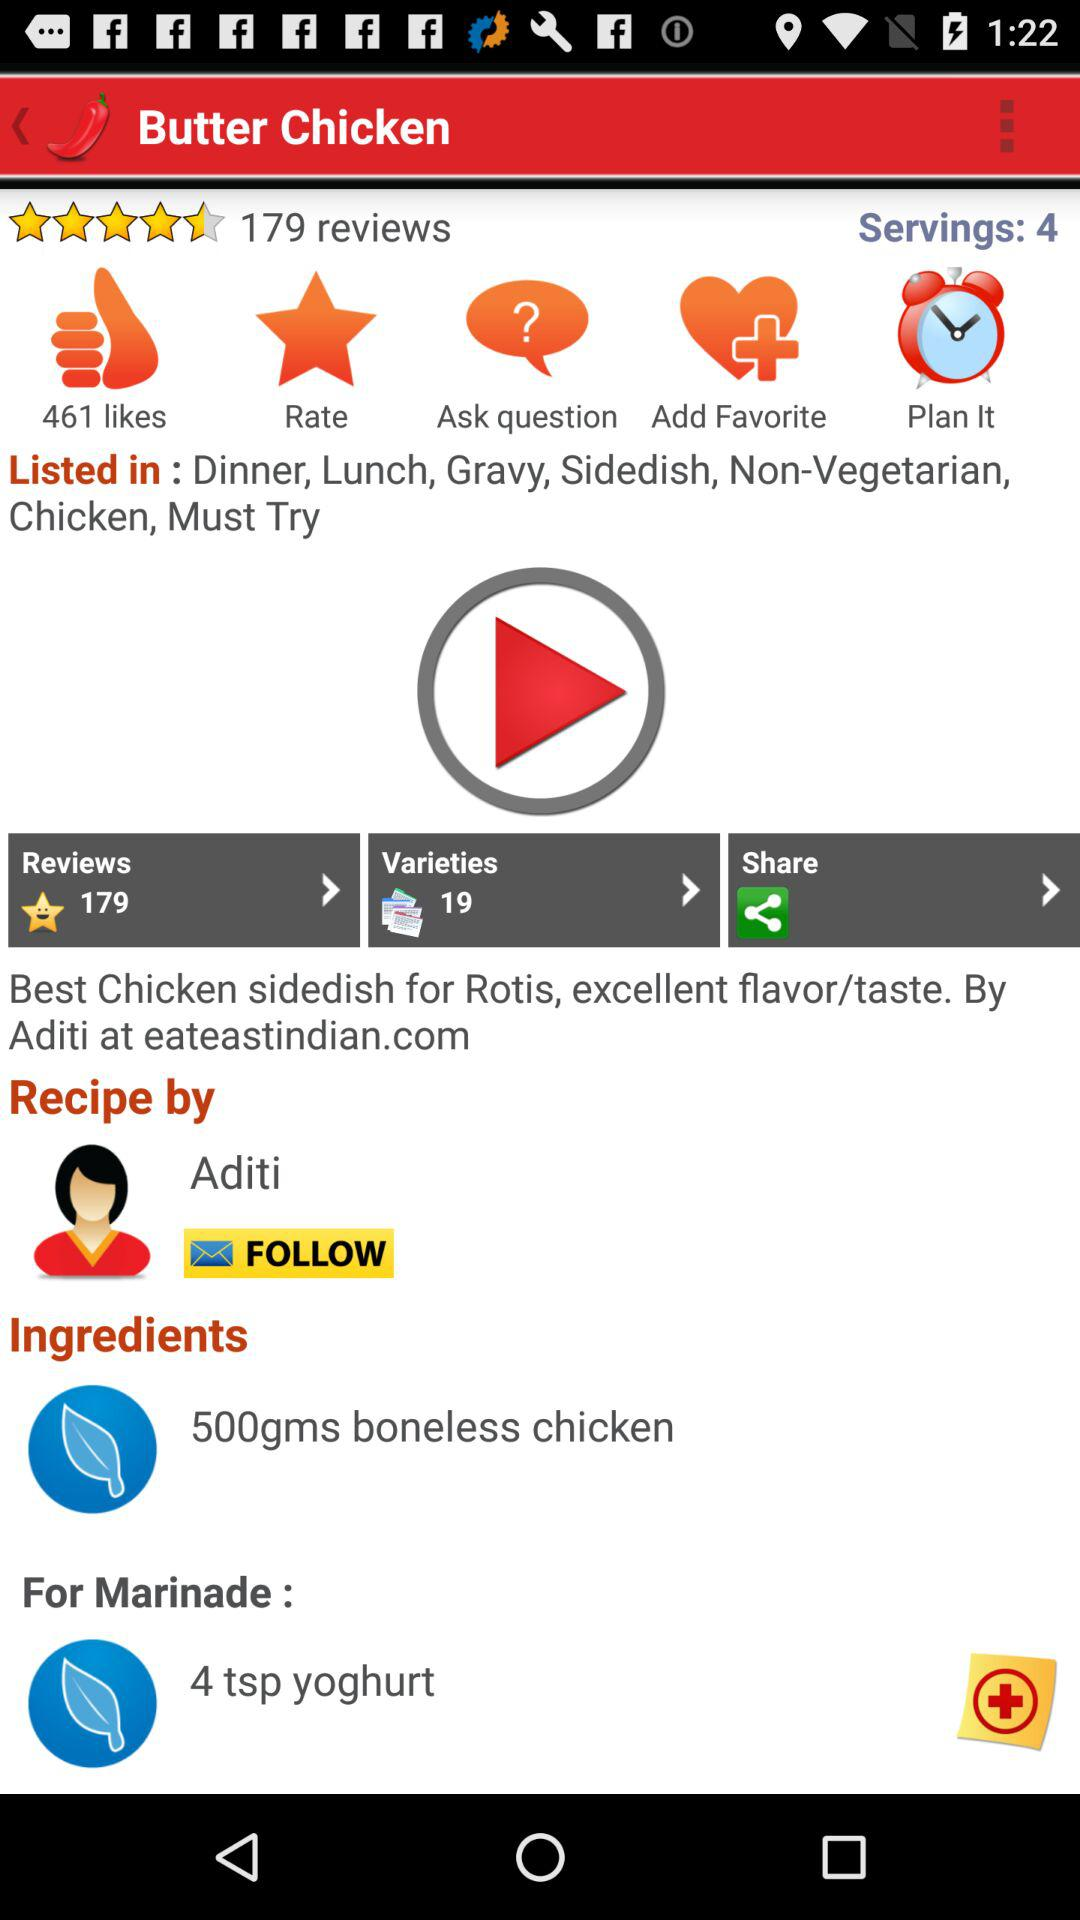How many varieties are there? There are 19 varieties. 